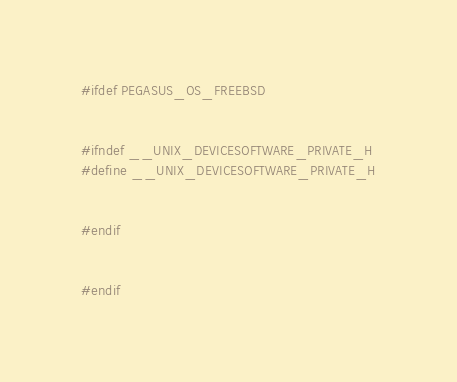Convert code to text. <code><loc_0><loc_0><loc_500><loc_500><_C++_>#ifdef PEGASUS_OS_FREEBSD


#ifndef __UNIX_DEVICESOFTWARE_PRIVATE_H
#define __UNIX_DEVICESOFTWARE_PRIVATE_H


#endif


#endif
</code> 